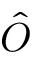Convert formula to latex. <formula><loc_0><loc_0><loc_500><loc_500>\hat { O }</formula> 